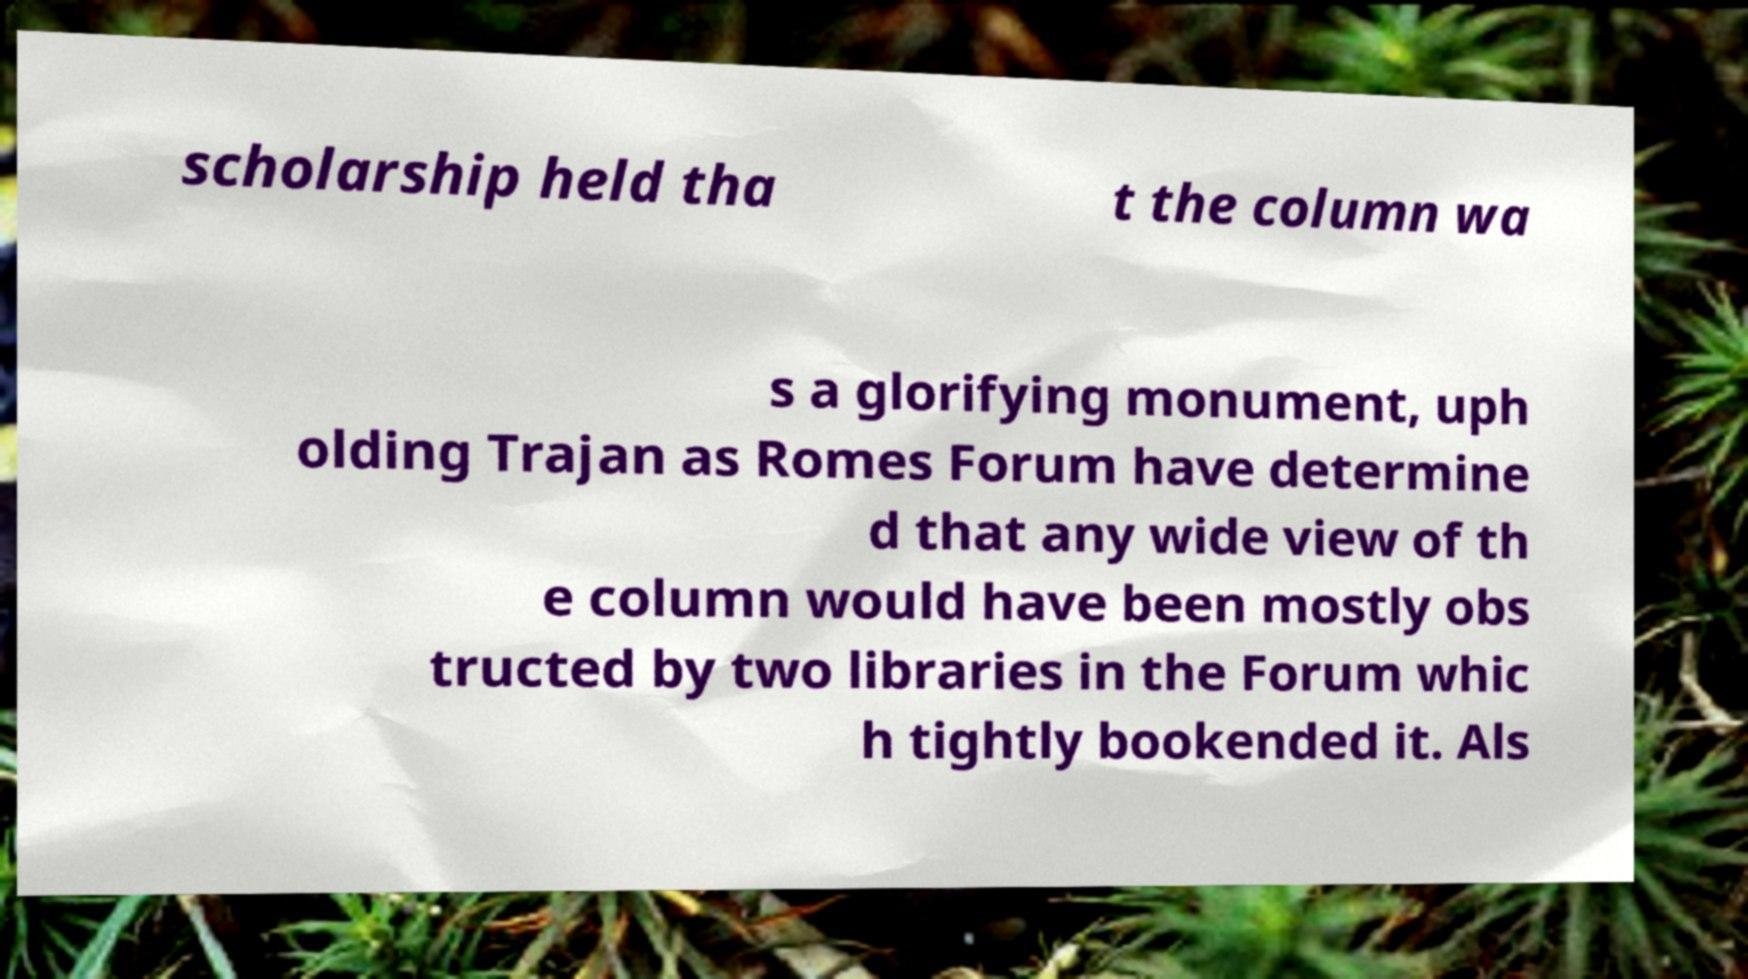Can you accurately transcribe the text from the provided image for me? scholarship held tha t the column wa s a glorifying monument, uph olding Trajan as Romes Forum have determine d that any wide view of th e column would have been mostly obs tructed by two libraries in the Forum whic h tightly bookended it. Als 